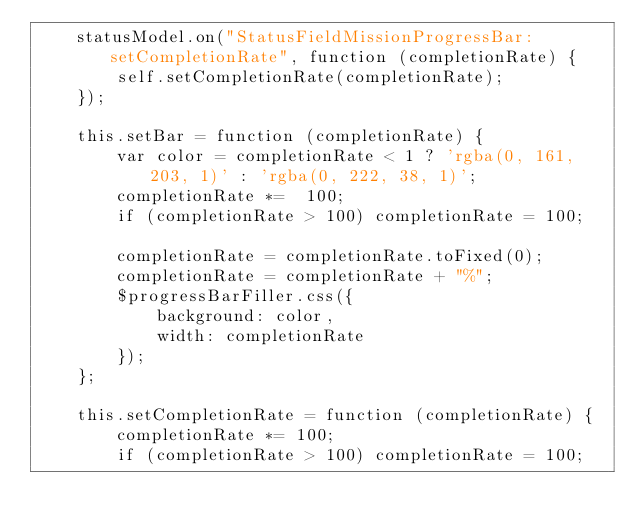<code> <loc_0><loc_0><loc_500><loc_500><_JavaScript_>    statusModel.on("StatusFieldMissionProgressBar:setCompletionRate", function (completionRate) {
        self.setCompletionRate(completionRate);
    });

    this.setBar = function (completionRate) {
        var color = completionRate < 1 ? 'rgba(0, 161, 203, 1)' : 'rgba(0, 222, 38, 1)';
        completionRate *=  100;
        if (completionRate > 100) completionRate = 100;

        completionRate = completionRate.toFixed(0);
        completionRate = completionRate + "%";
        $progressBarFiller.css({
            background: color,
            width: completionRate
        });
    };

    this.setCompletionRate = function (completionRate) {
        completionRate *= 100;
        if (completionRate > 100) completionRate = 100;</code> 